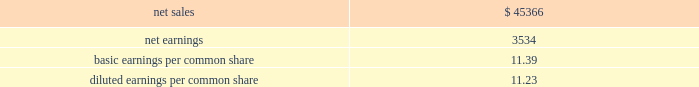Supplemental pro forma financial information ( unaudited ) the table presents summarized unaudited pro forma financial information as if sikorsky had been included in our financial results for the entire year in 2015 ( in millions ) : .
The unaudited supplemental pro forma financial data above has been calculated after applying our accounting policies and adjusting the historical results of sikorskywith pro forma adjustments , net of tax , that assume the acquisition occurred on january 1 , 2015 .
Significant pro forma adjustments include the recognition of additional amortization expense related to acquired intangible assets and additional interest expense related to the short-term debt used to finance the acquisition .
These adjustments assume the application of fair value adjustments to intangibles and the debt issuance occurred on january 1 , 2015 and are approximated as follows : amortization expense of $ 125million and interest expense of $ 40million .
In addition , significant nonrecurring adjustments include the elimination of a $ 72million pension curtailment loss , net of tax , recognized in 2015 and the elimination of a $ 58 million income tax charge related to historic earnings of foreign subsidiaries recognized by sikorsky in 2015 .
The unaudited supplemental pro forma financial information also reflects an increase in interest expense , net of tax , of approximately $ 110 million in 2015 .
The increase in interest expense is the result of assuming the november 2015 notes were issued on january 1 , 2015 .
Proceeds of the november 2015 notes were used to repay all outstanding borrowings under the 364- day facility used to finance a portion of the purchase price of sikorsky , as contemplated at the date of acquisition .
The unaudited supplemental pro forma financial information does not reflect the realization of any expected ongoing cost or revenue synergies relating to the integration of the two companies .
Further , the pro forma data should not be considered indicative of the results that would have occurred if the acquisition , related financing and associated notes issuance and repayment of the 364-day facility had been consummated on january 1 , 2015 , nor are they indicative of future results .
Consolidation of awemanagement limited on august 24 , 2016 , we increased our ownership interest in the awe joint venture , which operates the united kingdom 2019s nuclear deterrent program , from 33% ( 33 % ) to 51% ( 51 % ) .
At which time , we began consolidating awe .
Consequently , our operating results include 100% ( 100 % ) of awe 2019s sales and 51% ( 51 % ) of its operating profit .
Prior to increasing our ownership interest , we accounted for our investment inawe using the equity method of accounting .
Under the equity method , we recognized only 33% ( 33 % ) ofawe 2019s earnings or losses and no sales.accordingly , prior toaugust 24 , 2016 , the date we obtained control , we recorded 33%ofawe 2019s net earnings in our operating results and subsequent to august 24 , 2016 , we recognized 100% ( 100 % ) of awe 2019s sales and 51% ( 51 % ) of its operating profit .
We accounted for this transaction as a 201cstep acquisition 201d ( as defined by u.s .
Gaap ) , which requires us to consolidate and record the assets and liabilities ofawe at fair value.accordingly , we recorded intangible assets of $ 243million related to customer relationships , $ 32 million of net liabilities , and noncontrolling interests of $ 107 million .
The intangible assets are being amortized over a period of eight years in accordance with the underlying pattern of economic benefit reflected by the future net cash flows .
In 2016we recognized a non-cash net gain of $ 104million associatedwith obtaining a controlling interest inawewhich consisted of a $ 127 million pretax gain recognized in the operating results of our space business segment and $ 23 million of tax-related items at our corporate office .
The gain represents the fair value of our 51% ( 51 % ) interest inawe , less the carrying value of our previously held investment inawe and deferred taxes .
The gainwas recorded in other income , net on our consolidated statements of earnings .
The fair value ofawe ( including the intangible assets ) , our controlling interest , and the noncontrolling interests were determined using the income approach .
Divestiture of the information systems & global solutions business onaugust 16 , 2016wedivested our former is&gsbusinesswhichmergedwithleidos , in areversemorristrust transactionrr ( the 201ctransaction 201d ) .
The transaction was completed in a multi-step process pursuant to which we initially contributed the is&gs business to abacus innovations corporation ( abacus ) , a wholly owned subsidiary of lockheed martin created to facilitate the transaction , and the common stock ofabacus was distributed to participating lockheedmartin stockholders through an exchange offer .
Under the terms of the exchange offer , lockheedmartin stockholders had the option to exchange shares of lockheedmartin common stock for shares of abacus common stock .
At the conclusion of the exchange offer , all shares of abacus common stock were exchanged for 9369694 shares of lockheed martin common stock held by lockheed martin stockholders that elected to participate in the exchange.the shares of lockheedmartin common stock thatwere exchanged and acceptedwere retired , reducing the number of shares of our common stock outstanding by approximately 3% ( 3 % ) .
Following the exchange offer , abacus merged with .
What was the tax rate associated with the recognized a non-cash net gain from obtaining a controlling interest in awe? 
Computations: (23 / 127)
Answer: 0.1811. 